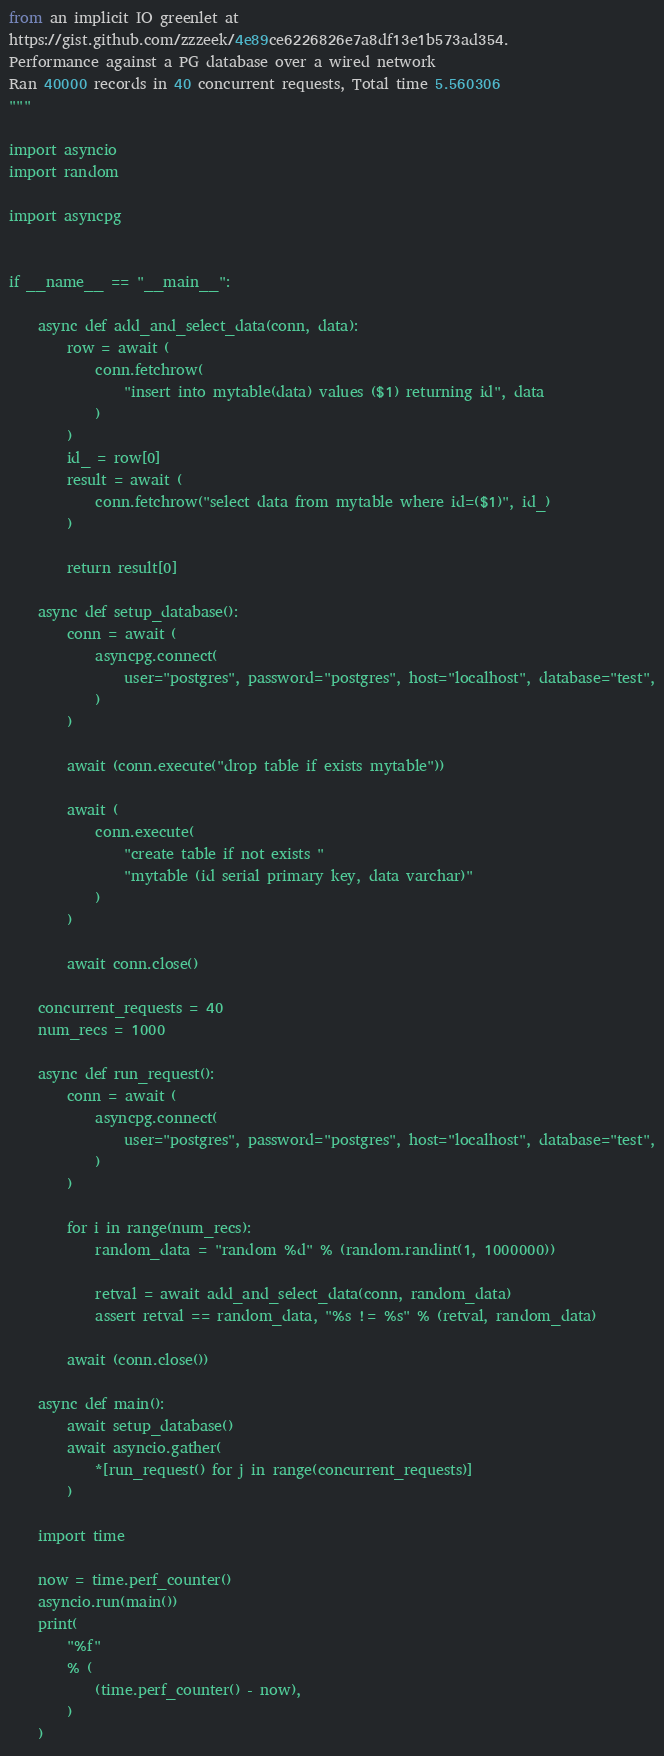<code> <loc_0><loc_0><loc_500><loc_500><_Python_>from an implicit IO greenlet at
https://gist.github.com/zzzeek/4e89ce6226826e7a8df13e1b573ad354.
Performance against a PG database over a wired network
Ran 40000 records in 40 concurrent requests, Total time 5.560306
"""

import asyncio
import random

import asyncpg


if __name__ == "__main__":

    async def add_and_select_data(conn, data):
        row = await (
            conn.fetchrow(
                "insert into mytable(data) values ($1) returning id", data
            )
        )
        id_ = row[0]
        result = await (
            conn.fetchrow("select data from mytable where id=($1)", id_)
        )

        return result[0]

    async def setup_database():
        conn = await (
            asyncpg.connect(
                user="postgres", password="postgres", host="localhost", database="test",
            )
        )

        await (conn.execute("drop table if exists mytable"))

        await (
            conn.execute(
                "create table if not exists "
                "mytable (id serial primary key, data varchar)"
            )
        )

        await conn.close()

    concurrent_requests = 40
    num_recs = 1000

    async def run_request():
        conn = await (
            asyncpg.connect(
                user="postgres", password="postgres", host="localhost", database="test",
            )
        )

        for i in range(num_recs):
            random_data = "random %d" % (random.randint(1, 1000000))

            retval = await add_and_select_data(conn, random_data)
            assert retval == random_data, "%s != %s" % (retval, random_data)

        await (conn.close())

    async def main():
        await setup_database()
        await asyncio.gather(
            *[run_request() for j in range(concurrent_requests)]
        )

    import time

    now = time.perf_counter()
    asyncio.run(main())
    print(
        "%f"
        % (
            (time.perf_counter() - now),
        )
    )
</code> 